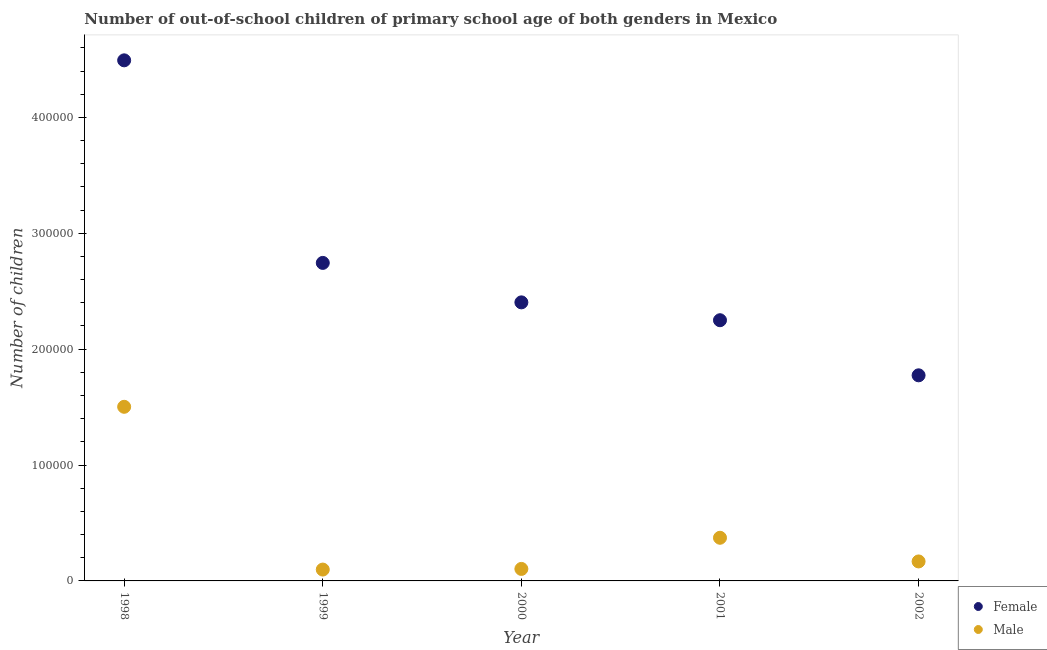What is the number of female out-of-school students in 1998?
Give a very brief answer. 4.49e+05. Across all years, what is the maximum number of male out-of-school students?
Offer a terse response. 1.50e+05. Across all years, what is the minimum number of male out-of-school students?
Keep it short and to the point. 9792. In which year was the number of female out-of-school students maximum?
Ensure brevity in your answer.  1998. In which year was the number of female out-of-school students minimum?
Provide a short and direct response. 2002. What is the total number of male out-of-school students in the graph?
Offer a terse response. 2.24e+05. What is the difference between the number of male out-of-school students in 2001 and that in 2002?
Provide a short and direct response. 2.04e+04. What is the difference between the number of female out-of-school students in 2001 and the number of male out-of-school students in 2002?
Give a very brief answer. 2.08e+05. What is the average number of male out-of-school students per year?
Your answer should be compact. 4.49e+04. In the year 2002, what is the difference between the number of male out-of-school students and number of female out-of-school students?
Provide a short and direct response. -1.61e+05. In how many years, is the number of female out-of-school students greater than 80000?
Give a very brief answer. 5. What is the ratio of the number of female out-of-school students in 1998 to that in 2002?
Provide a succinct answer. 2.53. Is the number of female out-of-school students in 2000 less than that in 2001?
Ensure brevity in your answer.  No. Is the difference between the number of female out-of-school students in 1999 and 2000 greater than the difference between the number of male out-of-school students in 1999 and 2000?
Offer a very short reply. Yes. What is the difference between the highest and the second highest number of male out-of-school students?
Make the answer very short. 1.13e+05. What is the difference between the highest and the lowest number of female out-of-school students?
Provide a short and direct response. 2.72e+05. In how many years, is the number of male out-of-school students greater than the average number of male out-of-school students taken over all years?
Offer a very short reply. 1. Is the sum of the number of male out-of-school students in 1998 and 2001 greater than the maximum number of female out-of-school students across all years?
Provide a short and direct response. No. Does the number of female out-of-school students monotonically increase over the years?
Ensure brevity in your answer.  No. Is the number of female out-of-school students strictly greater than the number of male out-of-school students over the years?
Make the answer very short. Yes. How many dotlines are there?
Provide a succinct answer. 2. How many years are there in the graph?
Ensure brevity in your answer.  5. What is the difference between two consecutive major ticks on the Y-axis?
Offer a very short reply. 1.00e+05. Are the values on the major ticks of Y-axis written in scientific E-notation?
Make the answer very short. No. Does the graph contain any zero values?
Offer a terse response. No. How are the legend labels stacked?
Provide a succinct answer. Vertical. What is the title of the graph?
Offer a terse response. Number of out-of-school children of primary school age of both genders in Mexico. What is the label or title of the Y-axis?
Offer a terse response. Number of children. What is the Number of children of Female in 1998?
Provide a succinct answer. 4.49e+05. What is the Number of children of Male in 1998?
Your answer should be compact. 1.50e+05. What is the Number of children of Female in 1999?
Give a very brief answer. 2.74e+05. What is the Number of children in Male in 1999?
Your answer should be very brief. 9792. What is the Number of children of Female in 2000?
Your answer should be very brief. 2.40e+05. What is the Number of children in Male in 2000?
Provide a short and direct response. 1.04e+04. What is the Number of children of Female in 2001?
Keep it short and to the point. 2.25e+05. What is the Number of children in Male in 2001?
Ensure brevity in your answer.  3.72e+04. What is the Number of children in Female in 2002?
Provide a succinct answer. 1.77e+05. What is the Number of children of Male in 2002?
Your response must be concise. 1.68e+04. Across all years, what is the maximum Number of children in Female?
Provide a short and direct response. 4.49e+05. Across all years, what is the maximum Number of children in Male?
Your answer should be very brief. 1.50e+05. Across all years, what is the minimum Number of children of Female?
Your response must be concise. 1.77e+05. Across all years, what is the minimum Number of children in Male?
Your answer should be very brief. 9792. What is the total Number of children in Female in the graph?
Provide a succinct answer. 1.37e+06. What is the total Number of children in Male in the graph?
Make the answer very short. 2.24e+05. What is the difference between the Number of children of Female in 1998 and that in 1999?
Offer a terse response. 1.75e+05. What is the difference between the Number of children in Male in 1998 and that in 1999?
Keep it short and to the point. 1.40e+05. What is the difference between the Number of children of Female in 1998 and that in 2000?
Ensure brevity in your answer.  2.09e+05. What is the difference between the Number of children in Male in 1998 and that in 2000?
Your response must be concise. 1.40e+05. What is the difference between the Number of children in Female in 1998 and that in 2001?
Offer a terse response. 2.24e+05. What is the difference between the Number of children of Male in 1998 and that in 2001?
Offer a terse response. 1.13e+05. What is the difference between the Number of children of Female in 1998 and that in 2002?
Ensure brevity in your answer.  2.72e+05. What is the difference between the Number of children of Male in 1998 and that in 2002?
Make the answer very short. 1.33e+05. What is the difference between the Number of children in Female in 1999 and that in 2000?
Your answer should be very brief. 3.40e+04. What is the difference between the Number of children of Male in 1999 and that in 2000?
Make the answer very short. -564. What is the difference between the Number of children in Female in 1999 and that in 2001?
Your answer should be very brief. 4.95e+04. What is the difference between the Number of children of Male in 1999 and that in 2001?
Your response must be concise. -2.74e+04. What is the difference between the Number of children of Female in 1999 and that in 2002?
Your answer should be very brief. 9.70e+04. What is the difference between the Number of children of Male in 1999 and that in 2002?
Provide a succinct answer. -7019. What is the difference between the Number of children in Female in 2000 and that in 2001?
Your answer should be compact. 1.54e+04. What is the difference between the Number of children in Male in 2000 and that in 2001?
Your answer should be compact. -2.69e+04. What is the difference between the Number of children in Female in 2000 and that in 2002?
Provide a short and direct response. 6.30e+04. What is the difference between the Number of children of Male in 2000 and that in 2002?
Provide a succinct answer. -6455. What is the difference between the Number of children in Female in 2001 and that in 2002?
Your answer should be compact. 4.75e+04. What is the difference between the Number of children in Male in 2001 and that in 2002?
Offer a very short reply. 2.04e+04. What is the difference between the Number of children of Female in 1998 and the Number of children of Male in 1999?
Ensure brevity in your answer.  4.39e+05. What is the difference between the Number of children in Female in 1998 and the Number of children in Male in 2000?
Offer a very short reply. 4.39e+05. What is the difference between the Number of children of Female in 1998 and the Number of children of Male in 2001?
Offer a very short reply. 4.12e+05. What is the difference between the Number of children of Female in 1998 and the Number of children of Male in 2002?
Offer a very short reply. 4.32e+05. What is the difference between the Number of children in Female in 1999 and the Number of children in Male in 2000?
Ensure brevity in your answer.  2.64e+05. What is the difference between the Number of children in Female in 1999 and the Number of children in Male in 2001?
Provide a succinct answer. 2.37e+05. What is the difference between the Number of children of Female in 1999 and the Number of children of Male in 2002?
Give a very brief answer. 2.58e+05. What is the difference between the Number of children of Female in 2000 and the Number of children of Male in 2001?
Make the answer very short. 2.03e+05. What is the difference between the Number of children of Female in 2000 and the Number of children of Male in 2002?
Ensure brevity in your answer.  2.24e+05. What is the difference between the Number of children in Female in 2001 and the Number of children in Male in 2002?
Your response must be concise. 2.08e+05. What is the average Number of children in Female per year?
Ensure brevity in your answer.  2.73e+05. What is the average Number of children of Male per year?
Your response must be concise. 4.49e+04. In the year 1998, what is the difference between the Number of children of Female and Number of children of Male?
Your answer should be compact. 2.99e+05. In the year 1999, what is the difference between the Number of children in Female and Number of children in Male?
Make the answer very short. 2.65e+05. In the year 2000, what is the difference between the Number of children of Female and Number of children of Male?
Your answer should be compact. 2.30e+05. In the year 2001, what is the difference between the Number of children in Female and Number of children in Male?
Give a very brief answer. 1.88e+05. In the year 2002, what is the difference between the Number of children of Female and Number of children of Male?
Your response must be concise. 1.61e+05. What is the ratio of the Number of children in Female in 1998 to that in 1999?
Provide a succinct answer. 1.64. What is the ratio of the Number of children of Male in 1998 to that in 1999?
Make the answer very short. 15.34. What is the ratio of the Number of children of Female in 1998 to that in 2000?
Your answer should be very brief. 1.87. What is the ratio of the Number of children of Male in 1998 to that in 2000?
Your answer should be compact. 14.51. What is the ratio of the Number of children in Female in 1998 to that in 2001?
Your answer should be compact. 2. What is the ratio of the Number of children in Male in 1998 to that in 2001?
Offer a very short reply. 4.04. What is the ratio of the Number of children of Female in 1998 to that in 2002?
Provide a short and direct response. 2.53. What is the ratio of the Number of children in Male in 1998 to that in 2002?
Give a very brief answer. 8.94. What is the ratio of the Number of children in Female in 1999 to that in 2000?
Make the answer very short. 1.14. What is the ratio of the Number of children of Male in 1999 to that in 2000?
Your answer should be very brief. 0.95. What is the ratio of the Number of children in Female in 1999 to that in 2001?
Ensure brevity in your answer.  1.22. What is the ratio of the Number of children in Male in 1999 to that in 2001?
Offer a terse response. 0.26. What is the ratio of the Number of children of Female in 1999 to that in 2002?
Offer a very short reply. 1.55. What is the ratio of the Number of children in Male in 1999 to that in 2002?
Your answer should be compact. 0.58. What is the ratio of the Number of children in Female in 2000 to that in 2001?
Offer a very short reply. 1.07. What is the ratio of the Number of children of Male in 2000 to that in 2001?
Provide a short and direct response. 0.28. What is the ratio of the Number of children of Female in 2000 to that in 2002?
Offer a very short reply. 1.35. What is the ratio of the Number of children of Male in 2000 to that in 2002?
Provide a short and direct response. 0.62. What is the ratio of the Number of children in Female in 2001 to that in 2002?
Ensure brevity in your answer.  1.27. What is the ratio of the Number of children of Male in 2001 to that in 2002?
Provide a succinct answer. 2.21. What is the difference between the highest and the second highest Number of children in Female?
Provide a succinct answer. 1.75e+05. What is the difference between the highest and the second highest Number of children in Male?
Your response must be concise. 1.13e+05. What is the difference between the highest and the lowest Number of children of Female?
Provide a succinct answer. 2.72e+05. What is the difference between the highest and the lowest Number of children of Male?
Provide a succinct answer. 1.40e+05. 